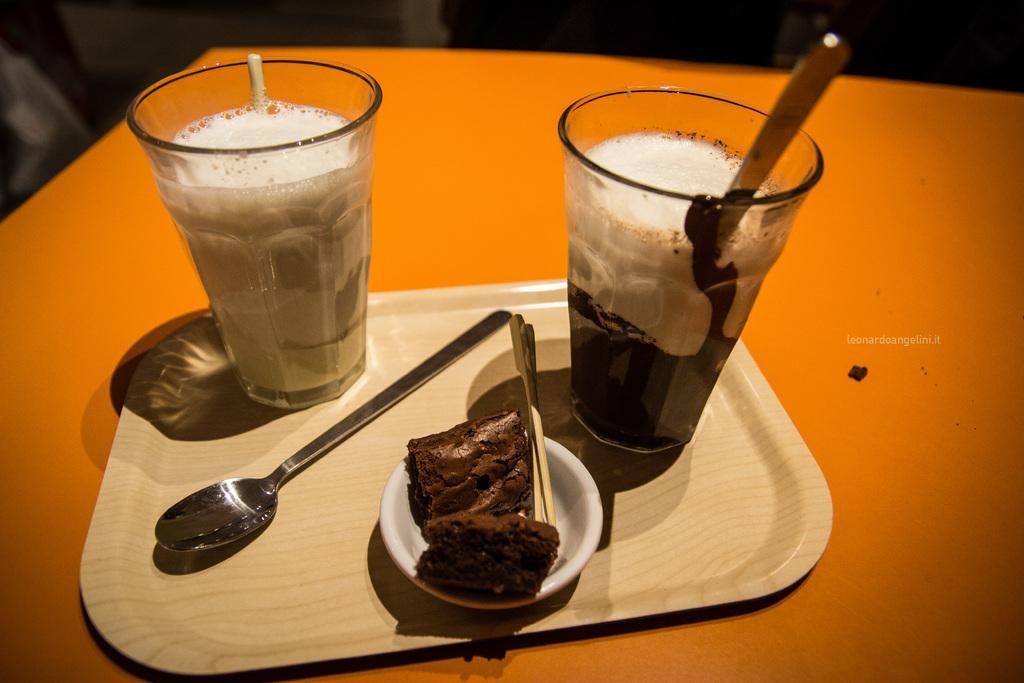Can you describe this image briefly? In this image we can see glasses with liquid, spoons, bowl, food, and toothpicks in a tray which is on the table. 